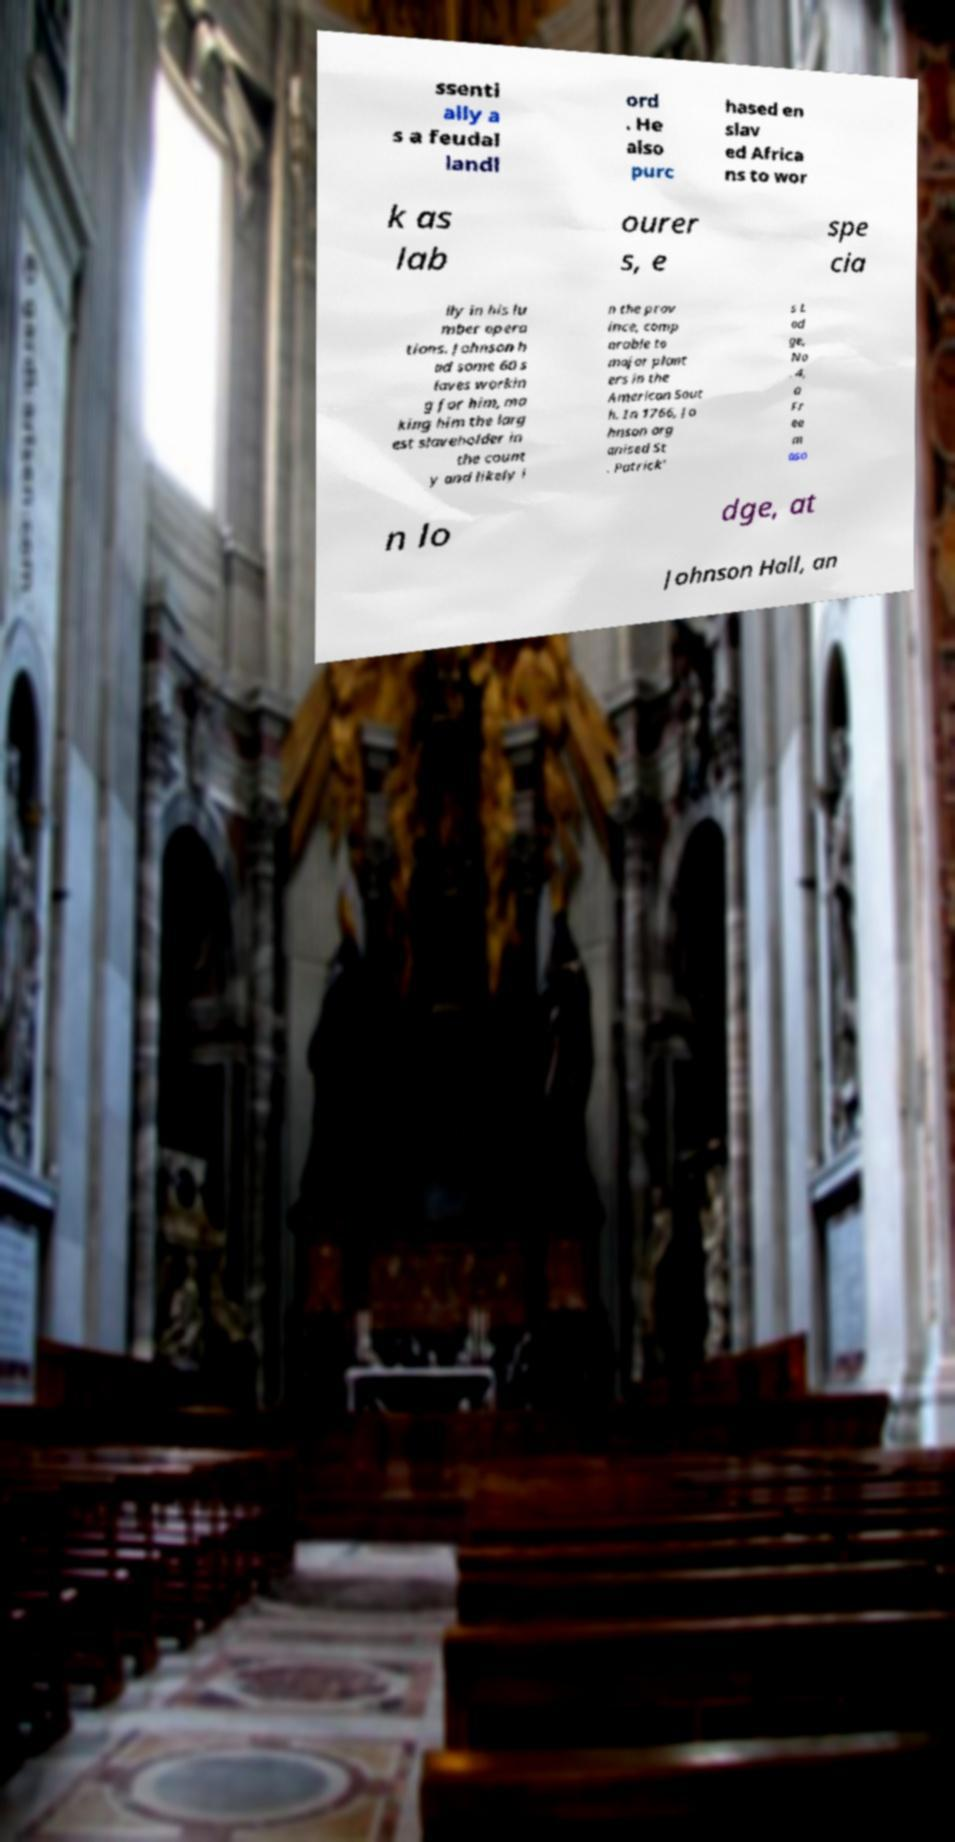Please identify and transcribe the text found in this image. ssenti ally a s a feudal landl ord . He also purc hased en slav ed Africa ns to wor k as lab ourer s, e spe cia lly in his lu mber opera tions. Johnson h ad some 60 s laves workin g for him, ma king him the larg est slaveholder in the count y and likely i n the prov ince, comp arable to major plant ers in the American Sout h. In 1766, Jo hnson org anised St . Patrick' s L od ge, No . 4, a Fr ee m aso n lo dge, at Johnson Hall, an 